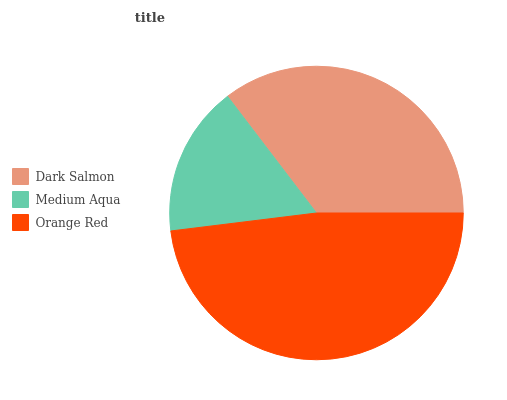Is Medium Aqua the minimum?
Answer yes or no. Yes. Is Orange Red the maximum?
Answer yes or no. Yes. Is Orange Red the minimum?
Answer yes or no. No. Is Medium Aqua the maximum?
Answer yes or no. No. Is Orange Red greater than Medium Aqua?
Answer yes or no. Yes. Is Medium Aqua less than Orange Red?
Answer yes or no. Yes. Is Medium Aqua greater than Orange Red?
Answer yes or no. No. Is Orange Red less than Medium Aqua?
Answer yes or no. No. Is Dark Salmon the high median?
Answer yes or no. Yes. Is Dark Salmon the low median?
Answer yes or no. Yes. Is Medium Aqua the high median?
Answer yes or no. No. Is Medium Aqua the low median?
Answer yes or no. No. 